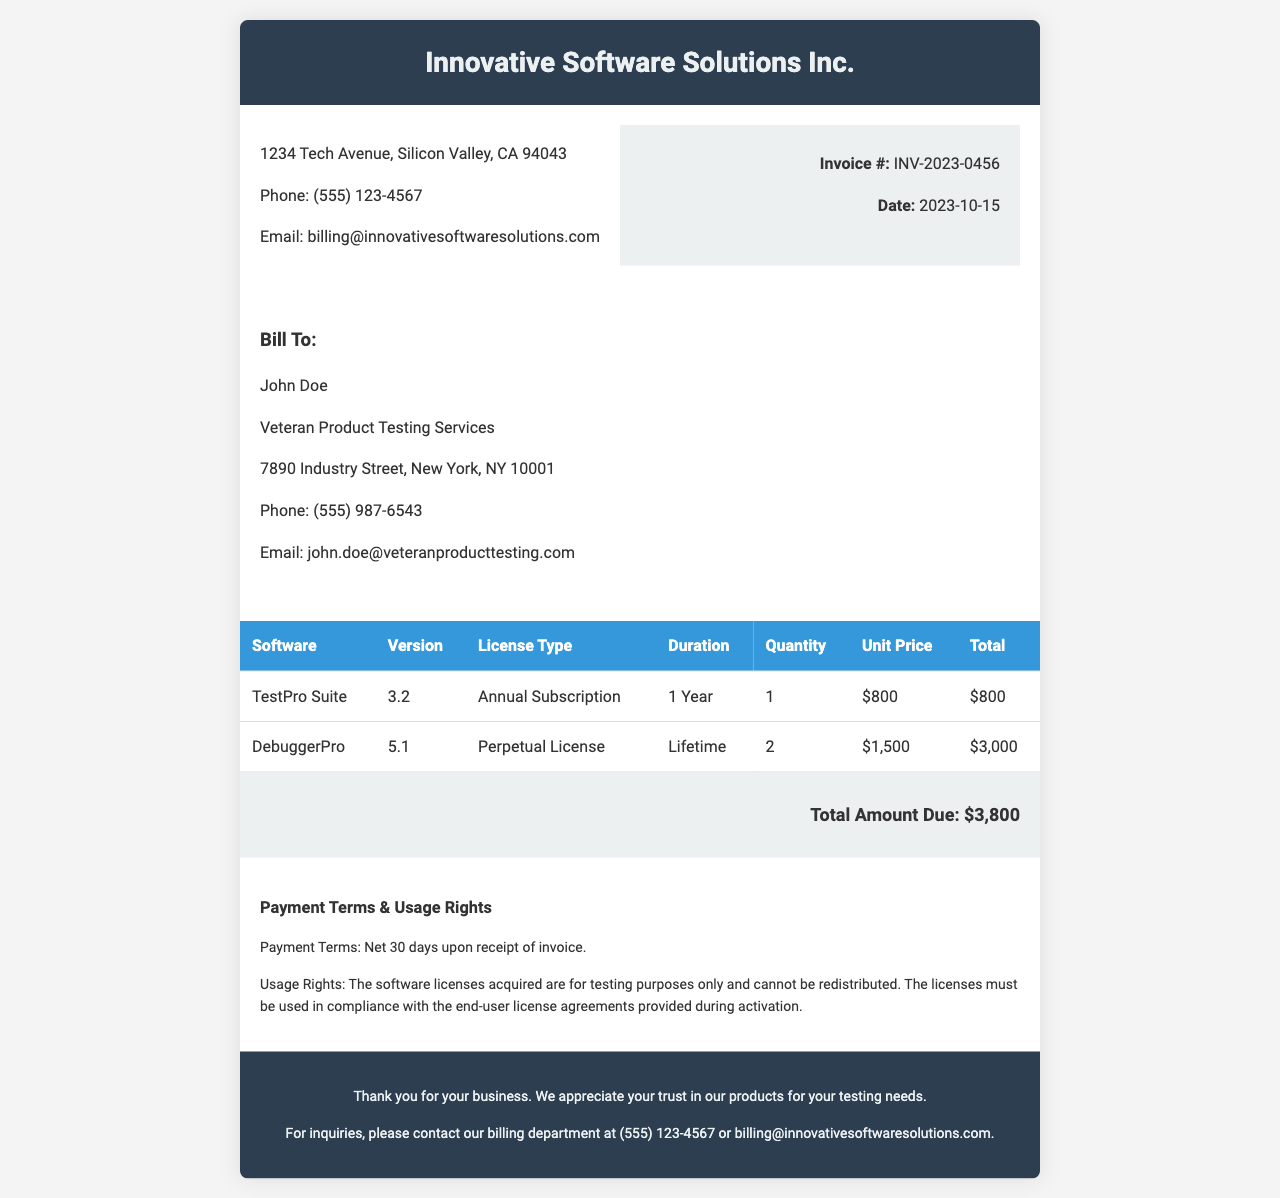what is the invoice number? The invoice number is listed under the invoice details section in the document as INV-2023-0456.
Answer: INV-2023-0456 who is the customer? The customer's information is located in the "Bill To" section, listing John Doe as the customer.
Answer: John Doe what is the total amount due? The total amount due is found in the total section at the bottom of the document, which states $3,800.
Answer: $3,800 how many licenses of DebuggerPro are included? The quantity of DebuggerPro licenses is located in the table, indicating that 2 licenses are included.
Answer: 2 what are the payment terms? The payment terms are included in the terms section, stating that payment is due within 30 days.
Answer: Net 30 days what is the usage rights for the software? The usage rights state that the software licenses can only be used for testing purposes and cannot be redistributed.
Answer: For testing purposes only what is the duration of the TestPro Suite license? The duration for the TestPro Suite license is stated in the table as 1 Year.
Answer: 1 Year when was the invoice issued? The date of the invoice can be found in the invoice details section, which is listed as 2023-10-15.
Answer: 2023-10-15 who is the billing contact? The billing contact information is provided in the footer of the document, specifying the phone number and email for inquiries.
Answer: (555) 123-4567 or billing@innovativesoftwaresolutions.com 